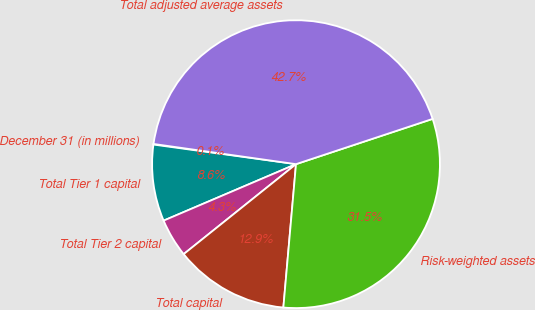Convert chart to OTSL. <chart><loc_0><loc_0><loc_500><loc_500><pie_chart><fcel>December 31 (in millions)<fcel>Total Tier 1 capital<fcel>Total Tier 2 capital<fcel>Total capital<fcel>Risk-weighted assets<fcel>Total adjusted average assets<nl><fcel>0.07%<fcel>8.59%<fcel>4.33%<fcel>12.85%<fcel>31.49%<fcel>42.66%<nl></chart> 